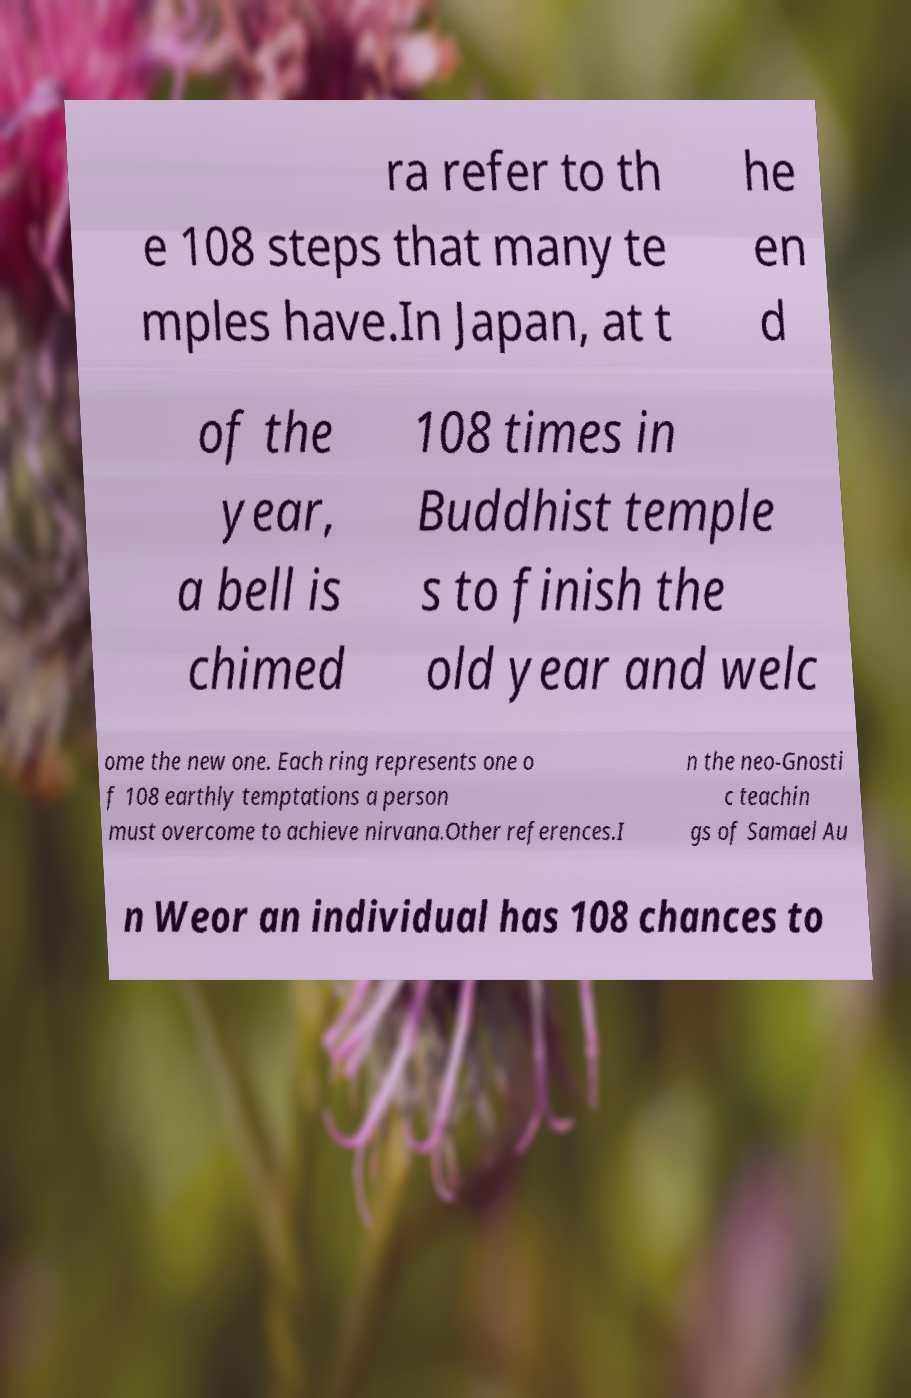Could you extract and type out the text from this image? ra refer to th e 108 steps that many te mples have.In Japan, at t he en d of the year, a bell is chimed 108 times in Buddhist temple s to finish the old year and welc ome the new one. Each ring represents one o f 108 earthly temptations a person must overcome to achieve nirvana.Other references.I n the neo-Gnosti c teachin gs of Samael Au n Weor an individual has 108 chances to 